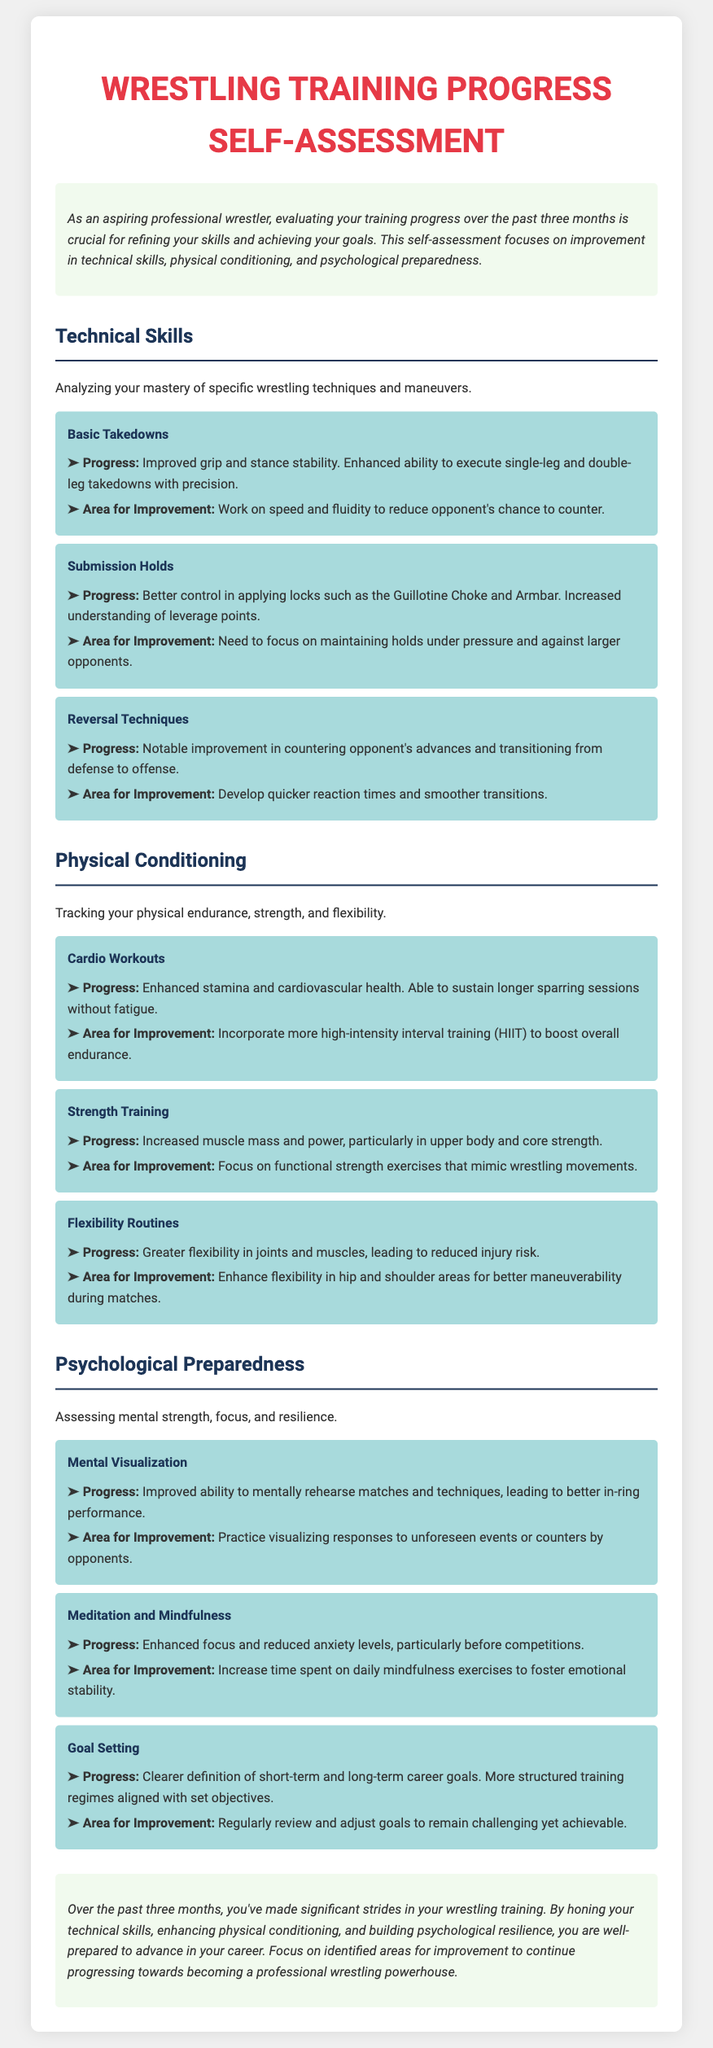What is the focus of the self-assessment? The document states that the self-assessment focuses on improvement in technical skills, physical conditioning, and psychological preparedness.
Answer: technical skills, physical conditioning, psychological preparedness What was the improvement mentioned in Basic Takedowns? The document highlights improved grip and stance stability, enhancing the ability to execute takedowns with precision.
Answer: Improved grip and stance stability What area for improvement is identified for Submission Holds? The document specifies the need to focus on maintaining holds under pressure and against larger opponents.
Answer: Maintaining holds under pressure How long was the recent training period evaluated? The introduction indicates that the self-assessment covers training progress over the past three months.
Answer: three months What is recommended for enhancing flexibility? The document suggests enhancing flexibility in hip and shoulder areas for better maneuverability during matches.
Answer: Hip and shoulder areas What mental technique has improved according to the assessment? The document notes an improved ability in mental visualization leading to better in-ring performance.
Answer: Mental visualization What type of training is mentioned to boost overall endurance? The document advises incorporating more high-intensity interval training (HIIT) to enhance endurance.
Answer: High-intensity interval training Which psychological area involves reducing anxiety levels? The assessment mentions meditation and mindfulness as techniques to enhance focus and reduce anxiety levels.
Answer: Meditation and mindfulness What should be regularly reviewed according to Goal Setting? The self-assessment emphasizes the need to regularly review and adjust goals to ensure they remain challenging yet achievable.
Answer: Regularly review and adjust goals 